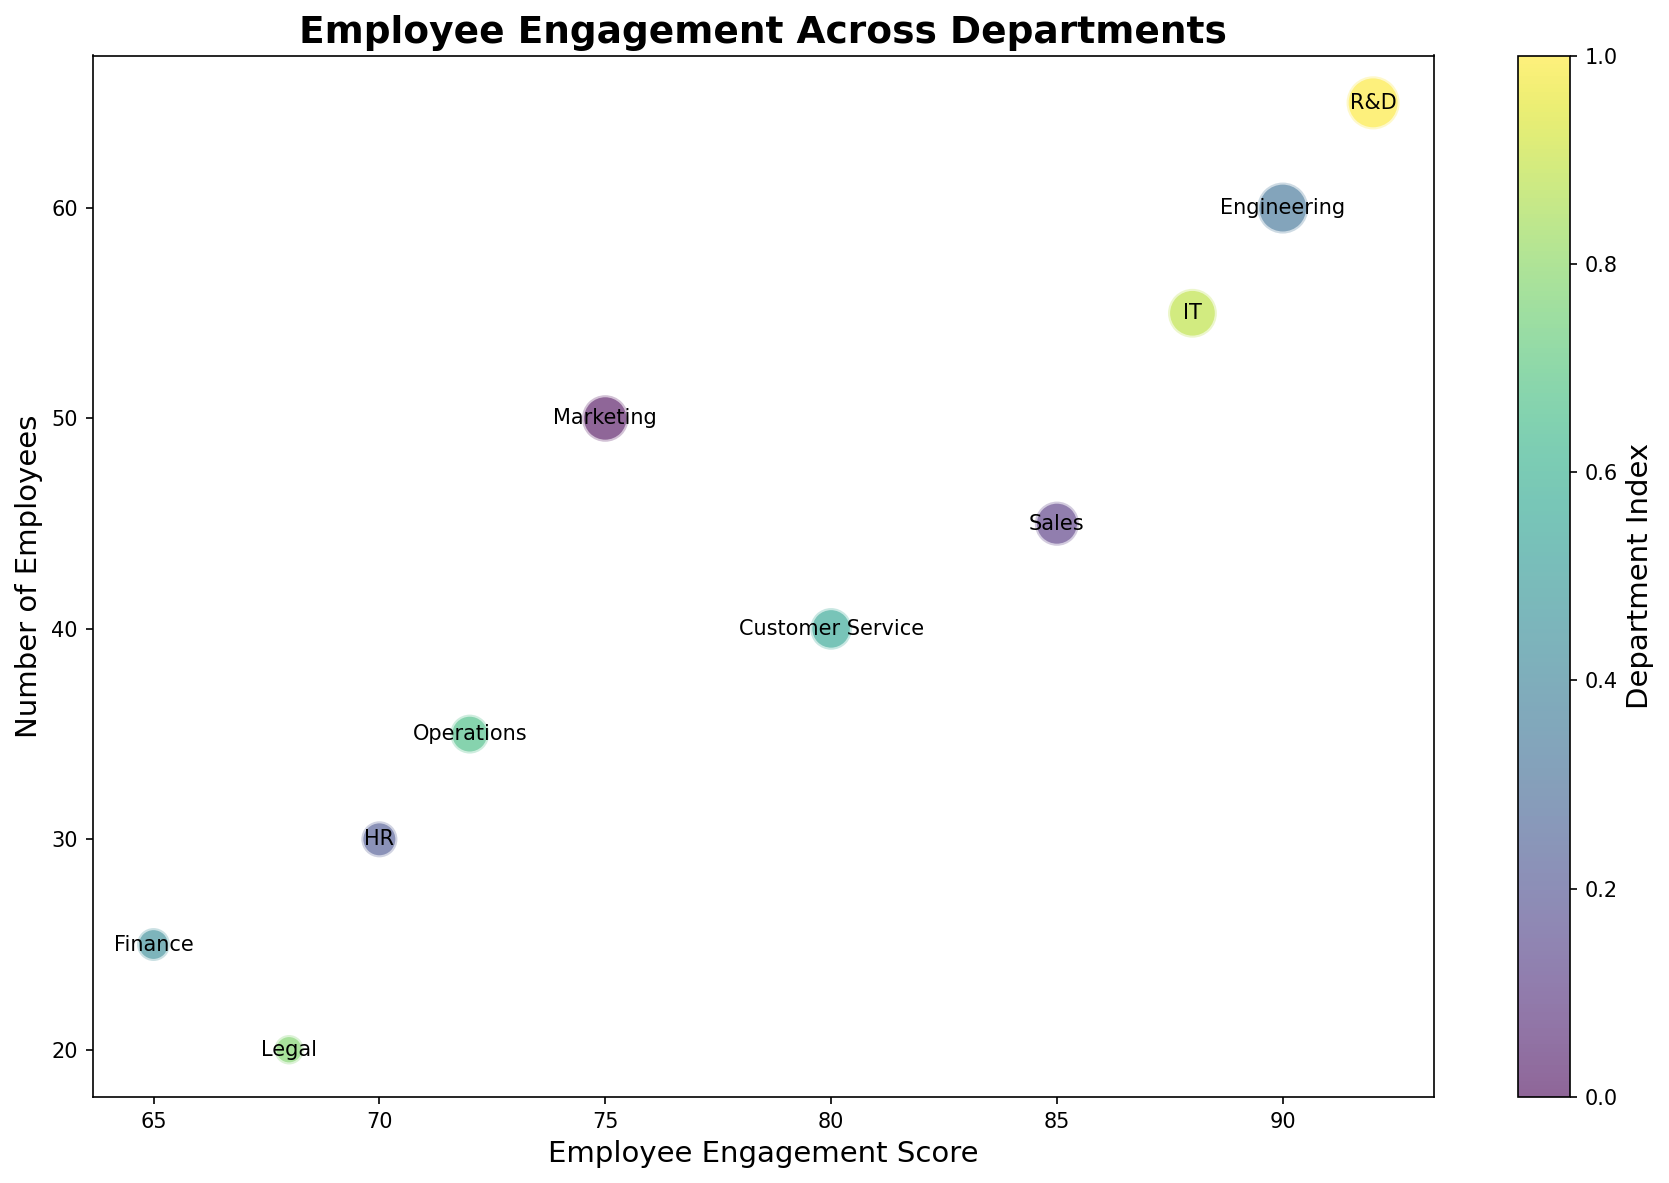Which department has the highest Employee Engagement Score? The highest Employee Engagement Score can be identified by finding the bubble farthest to the right. The Engineering department has the highest score of 92.
Answer: R&D Which department has the lowest Employee Engagement Score? The lowest Employee Engagement Score can be identified by finding the bubble farthest to the left. Finance has the lowest score of 65.
Answer: Finance What two departments have the most similar Employee Engagement Scores? By visually comparing the horizontal positions of the bubbles, Legal and HR appear to have the closest scores, with Legal at 68 and HR at 70.
Answer: Legal and HR What is the average Employee Engagement Score of the Sales and Marketing departments combined? Sales has a score of 85 and Marketing has 75. The average score is calculated as (85 + 75)/2.
Answer: 80 How many employees are there in total in the Engineering and IT departments? Summing up the Number of Employees in Engineering (60) and IT (55) gives the total.
Answer: 115 Which department uses the most tools as per the metadata? By examining the metadata, each department's tools can be counted. Each department listed uses two tools, so this question does not have a distinct answer from the plot alone.
Answer: All departments Which department has the largest bubble and what does it represent? The size of the bubble represents the Number of Employees. The largest bubble corresponds to R&D, which represents 65 employees.
Answer: R&D Which two departments are closest to each other in terms of Number of Employees? By visually comparing the vertical positions of the bubbles, Sales (45) and Customer Service (40) are closest.
Answer: Sales and Customer Service How does the number of employees in Marketing compare to Finance? Marketing has 50 employees, while Finance has 25 employees, so Marketing has twice as many employees as Finance.
Answer: Marketing > Finance What is the median Employee Engagement Score across all departments? Sorting the scores (65, 68, 70, 72, 75, 80, 85, 88, 90, 92), the middle value is found between the 5th and 6th scores. The median is (75 + 80)/2.
Answer: 77.5 